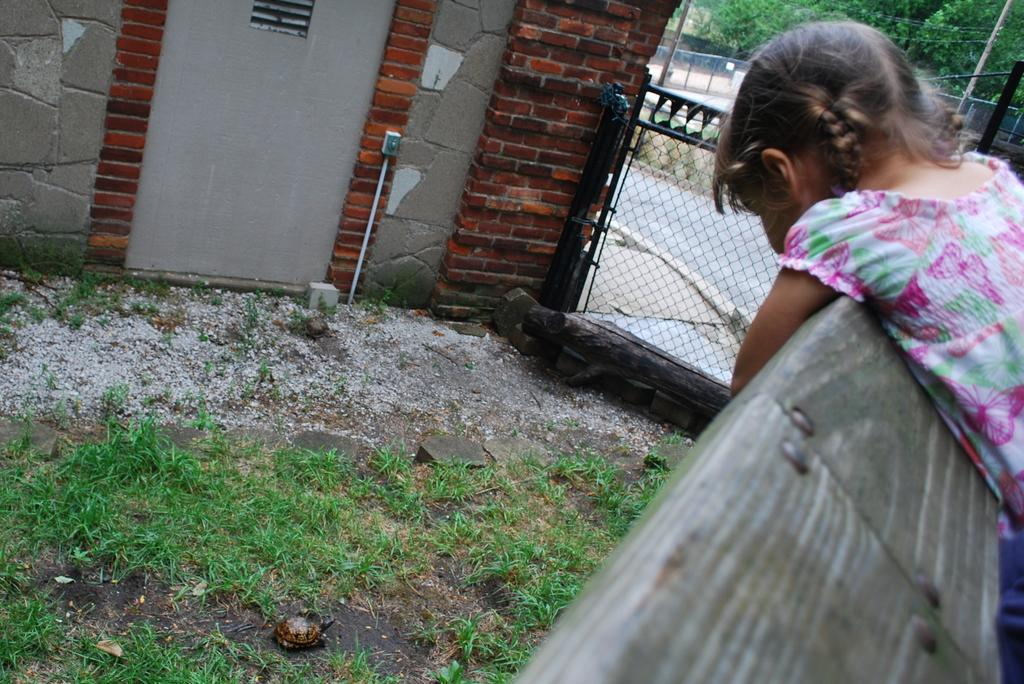Who is the main subject in the image? There is a small girl in the image. What is the girl doing in the image? The girl is bending on a wooden surface. What type of surface is the girl bending on? The wooden surface is near grass and a mesh. What can be seen behind the grass in the image? There is a wall beside the grass surface. How far away is the crowd from the girl in the image? There is no crowd present in the image, so it is not possible to determine the distance between the girl and a crowd. 